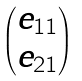<formula> <loc_0><loc_0><loc_500><loc_500>\begin{pmatrix} e _ { 1 1 } \\ e _ { 2 1 } \end{pmatrix}</formula> 